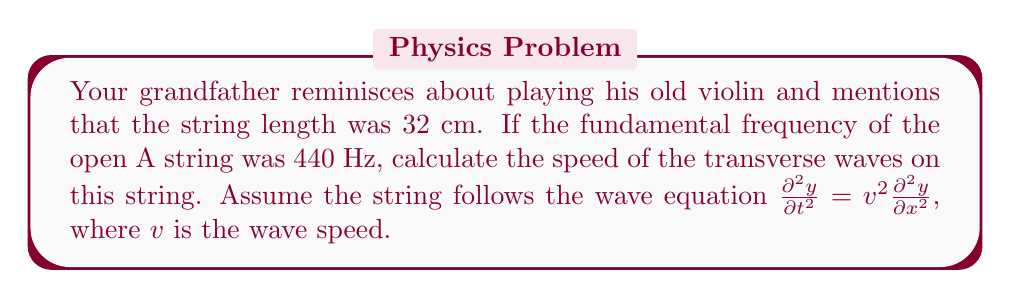Teach me how to tackle this problem. Let's approach this step-by-step:

1) For a string fixed at both ends, the fundamental frequency $f$ is related to the string length $L$ and wave speed $v$ by the equation:

   $$f = \frac{v}{2L}$$

2) We are given:
   - Fundamental frequency, $f = 440$ Hz
   - String length, $L = 32$ cm = 0.32 m

3) Rearranging the equation to solve for $v$:

   $$v = 2Lf$$

4) Substituting the known values:

   $$v = 2 \cdot 0.32 \text{ m} \cdot 440 \text{ Hz}$$

5) Calculating:

   $$v = 281.6 \text{ m/s}$$

6) Rounding to three significant figures:

   $$v \approx 282 \text{ m/s}$$

This speed represents how fast the transverse waves travel along the violin string.
Answer: 282 m/s 